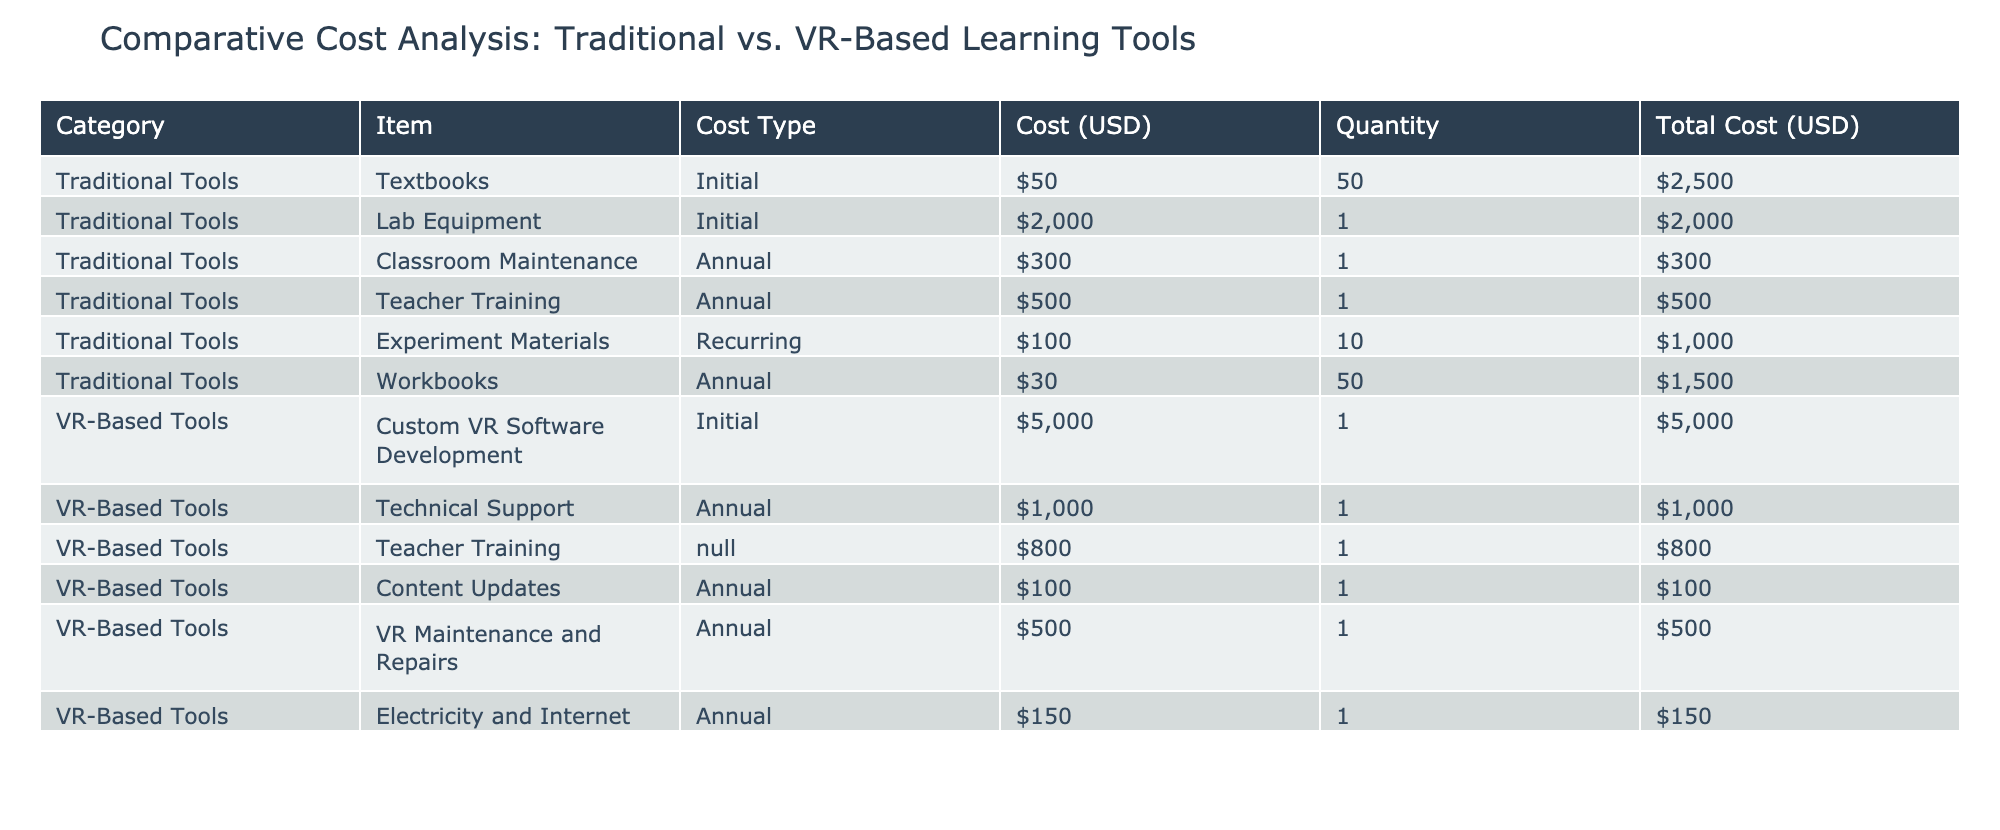What is the total cost of textbooks in the traditional tools category? The total cost of textbooks is listed under the "Total Cost (USD)" column for the "Textbooks" item in the Traditional Tools category. The value is $2500.
Answer: $2500 What is the annual cost for technical support in the VR-Based tools category? The table indicates that the annual cost for technical support is listed under the "Total Cost (USD)" column for the "Technical Support" item in the VR-Based Tools category, which is $1000.
Answer: $1000 Are the total costs for traditional tools higher than for VR-based tools? To compare the total costs, we sum all the "Total Cost (USD)" for both categories. Traditional tools total is $2500 (textbooks) + $2000 (lab equipment) + $300 (maintenance) + $500 (teacher training) + $1000 (experiment materials) + $1500 (workbooks) = $6800. For VR-based tools, the total is $5000 (software) + $1000 (technical support) + $800 (teacher training) + $100 (content updates) + $500 (maintenance) + $150 (electricity and internet) = $6750. Since $6800 is greater than $6750, the statement is true.
Answer: Yes What is the combined total cost of annual recurring costs for traditional tools? The annual recurring costs for traditional tools are the costs listed in the "Recurring Cost" and "Annual Cost" categories. This includes $300 (classroom maintenance), $500 (teacher training), and $1000 (experiment materials). Adding these gives a total of $300 + $500 + $1000 = $1800.
Answer: $1800 What is the difference in total costs between traditional tools and VR-based tools? As calculated earlier, the total costs for traditional tools is $6800 and for VR-based tools is $6750. The difference is $6800 - $6750 = $50.
Answer: $50 What is the average cost per item for the VR-based tools? To calculate the average cost per item, we take the total cost of all VR-based tools ($6750) and divide it by the number of items (6). Thus, $6750 / 6 = $1125.
Answer: $1125 Does the cost of custom VR software development exceed the total cost of lab equipment in traditional tools? The cost of custom VR software development is $5000 and the total cost of lab equipment in traditional tools is $2000. Since $5000 is greater than $2000, the statement is true.
Answer: Yes What is the total initial purchase cost for both categories combined? The initial purchase costs include $2500 (textbooks) + $2000 (lab equipment) + $5000 (VR software) + $800 (teacher training for VR). Adding these gives $2500 + $2000 + $5000 + $800 = $10300.
Answer: $10300 What is the total cost of teacher training across both categories? In the Traditional Tools category, the teacher training cost is $500 (annual), and for VR-based tools, it's $800 (initial cost). Adding these costs gives $500 + $800 = $1300.
Answer: $1300 